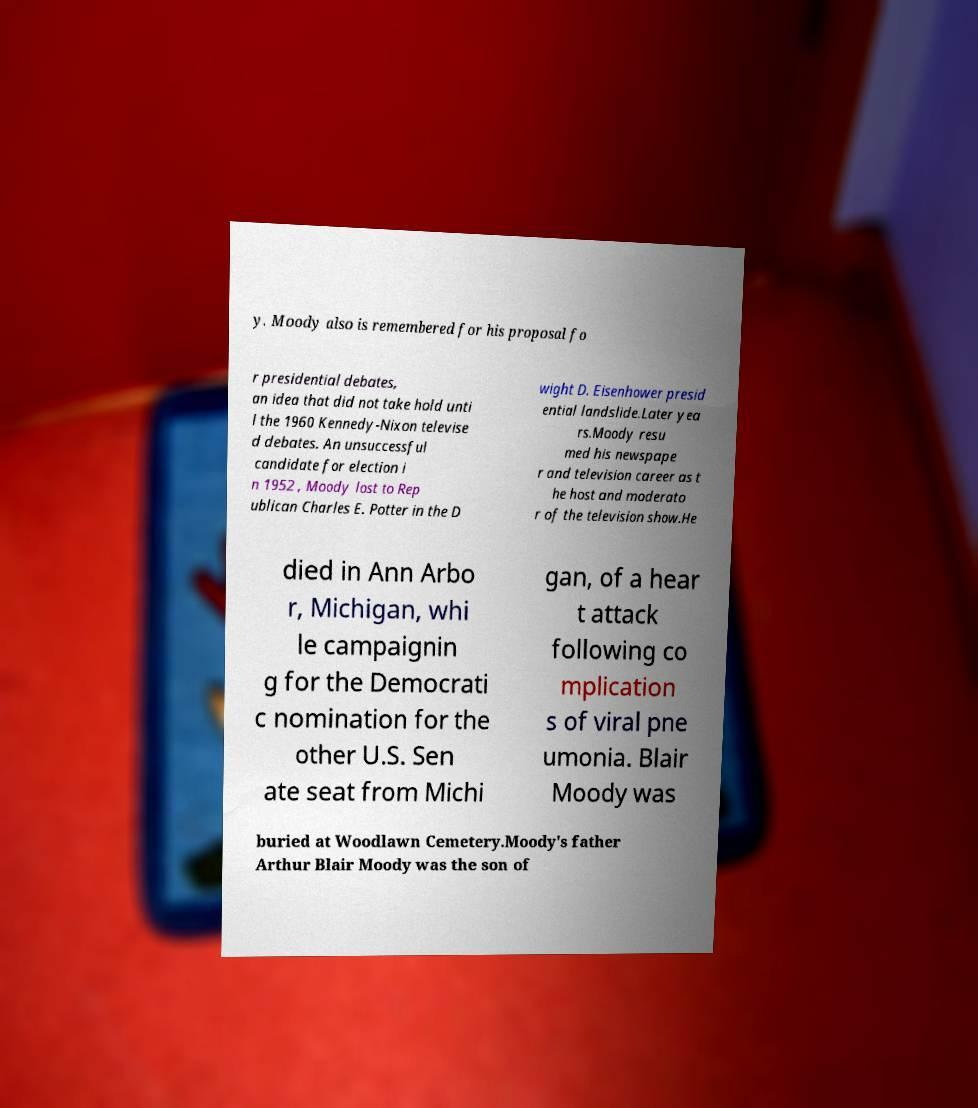Please read and relay the text visible in this image. What does it say? y. Moody also is remembered for his proposal fo r presidential debates, an idea that did not take hold unti l the 1960 Kennedy-Nixon televise d debates. An unsuccessful candidate for election i n 1952 , Moody lost to Rep ublican Charles E. Potter in the D wight D. Eisenhower presid ential landslide.Later yea rs.Moody resu med his newspape r and television career as t he host and moderato r of the television show.He died in Ann Arbo r, Michigan, whi le campaignin g for the Democrati c nomination for the other U.S. Sen ate seat from Michi gan, of a hear t attack following co mplication s of viral pne umonia. Blair Moody was buried at Woodlawn Cemetery.Moody's father Arthur Blair Moody was the son of 